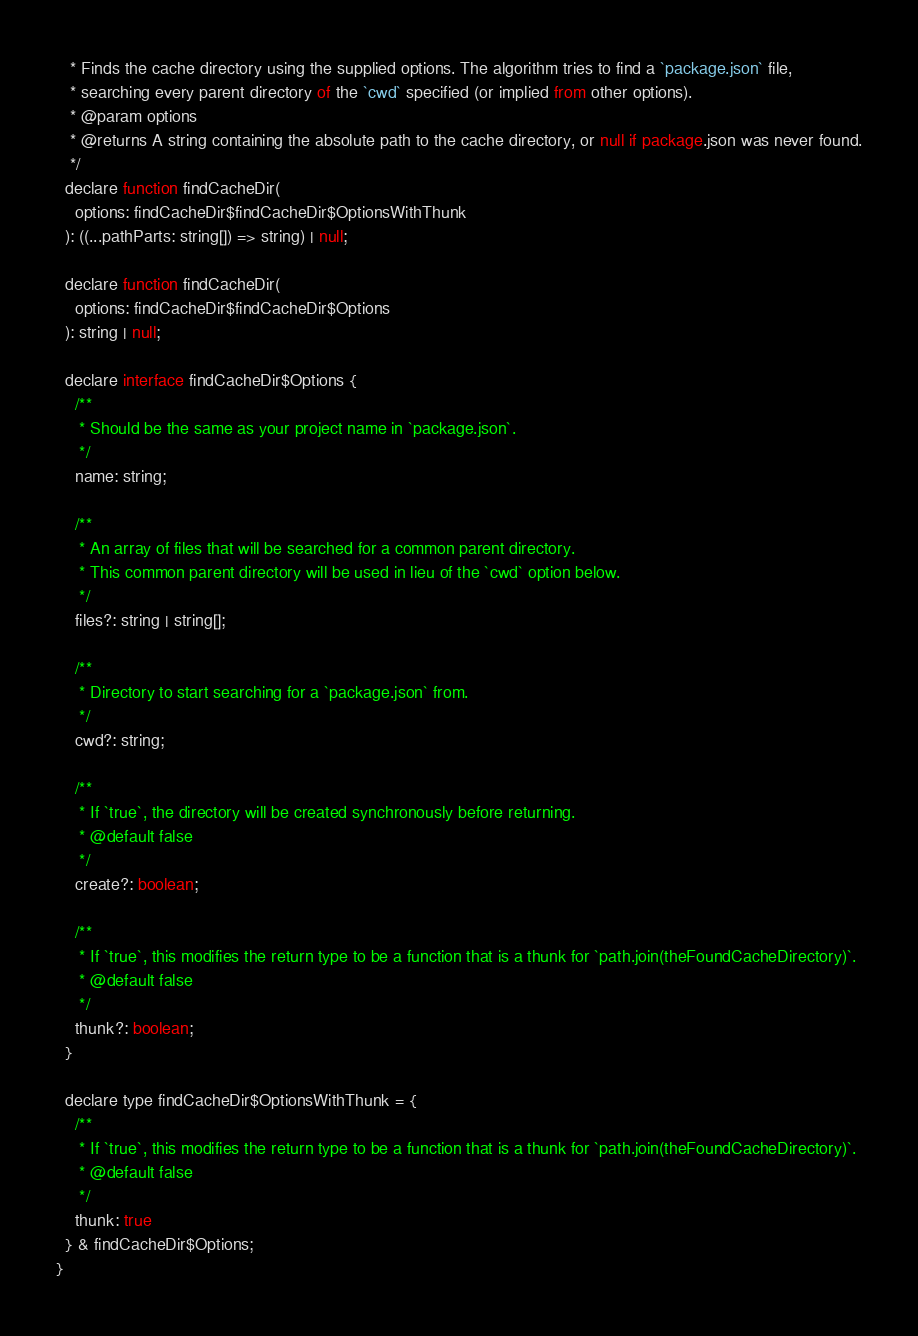Convert code to text. <code><loc_0><loc_0><loc_500><loc_500><_JavaScript_>   * Finds the cache directory using the supplied options. The algorithm tries to find a `package.json` file,
   * searching every parent directory of the `cwd` specified (or implied from other options).
   * @param options
   * @returns A string containing the absolute path to the cache directory, or null if package.json was never found.
   */
  declare function findCacheDir(
    options: findCacheDir$findCacheDir$OptionsWithThunk
  ): ((...pathParts: string[]) => string) | null;

  declare function findCacheDir(
    options: findCacheDir$findCacheDir$Options
  ): string | null;

  declare interface findCacheDir$Options {
    /**
     * Should be the same as your project name in `package.json`.
     */
    name: string;

    /**
     * An array of files that will be searched for a common parent directory.
     * This common parent directory will be used in lieu of the `cwd` option below.
     */
    files?: string | string[];

    /**
     * Directory to start searching for a `package.json` from.
     */
    cwd?: string;

    /**
     * If `true`, the directory will be created synchronously before returning.
     * @default false
     */
    create?: boolean;

    /**
     * If `true`, this modifies the return type to be a function that is a thunk for `path.join(theFoundCacheDirectory)`.
     * @default false
     */
    thunk?: boolean;
  }

  declare type findCacheDir$OptionsWithThunk = {
    /**
     * If `true`, this modifies the return type to be a function that is a thunk for `path.join(theFoundCacheDirectory)`.
     * @default false
     */
    thunk: true
  } & findCacheDir$Options;
}
</code> 